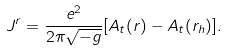Convert formula to latex. <formula><loc_0><loc_0><loc_500><loc_500>J ^ { r } = \frac { e ^ { 2 } } { 2 \pi \sqrt { - g } } [ A _ { t } ( r ) - A _ { t } ( r _ { h } ) ] .</formula> 